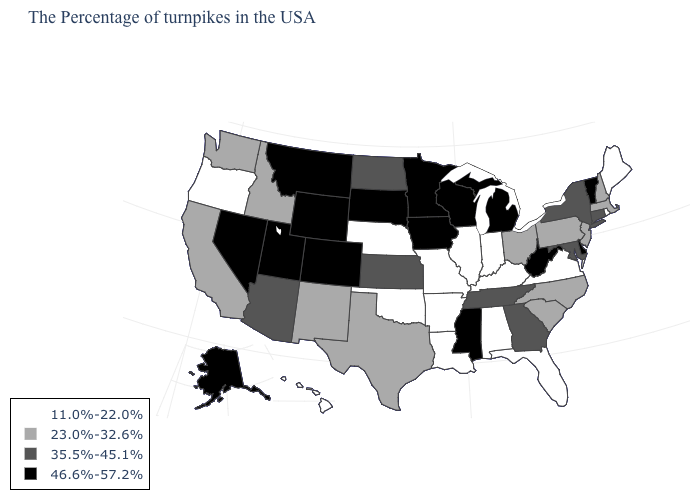What is the value of Iowa?
Keep it brief. 46.6%-57.2%. Among the states that border Utah , which have the highest value?
Keep it brief. Wyoming, Colorado, Nevada. What is the value of South Carolina?
Concise answer only. 23.0%-32.6%. Does Iowa have the same value as Delaware?
Write a very short answer. Yes. Does South Carolina have the highest value in the South?
Answer briefly. No. What is the lowest value in the Northeast?
Write a very short answer. 11.0%-22.0%. Name the states that have a value in the range 11.0%-22.0%?
Quick response, please. Maine, Rhode Island, Virginia, Florida, Kentucky, Indiana, Alabama, Illinois, Louisiana, Missouri, Arkansas, Nebraska, Oklahoma, Oregon, Hawaii. Does Nevada have a higher value than West Virginia?
Keep it brief. No. Does Virginia have a lower value than Idaho?
Give a very brief answer. Yes. What is the value of Wisconsin?
Concise answer only. 46.6%-57.2%. Name the states that have a value in the range 35.5%-45.1%?
Answer briefly. Connecticut, New York, Maryland, Georgia, Tennessee, Kansas, North Dakota, Arizona. Which states have the highest value in the USA?
Quick response, please. Vermont, Delaware, West Virginia, Michigan, Wisconsin, Mississippi, Minnesota, Iowa, South Dakota, Wyoming, Colorado, Utah, Montana, Nevada, Alaska. Does the map have missing data?
Keep it brief. No. Name the states that have a value in the range 35.5%-45.1%?
Concise answer only. Connecticut, New York, Maryland, Georgia, Tennessee, Kansas, North Dakota, Arizona. 